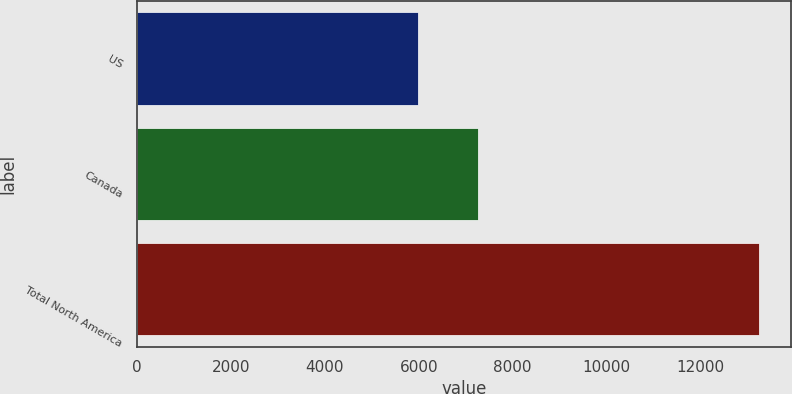Convert chart. <chart><loc_0><loc_0><loc_500><loc_500><bar_chart><fcel>US<fcel>Canada<fcel>Total North America<nl><fcel>5985<fcel>7271<fcel>13256<nl></chart> 